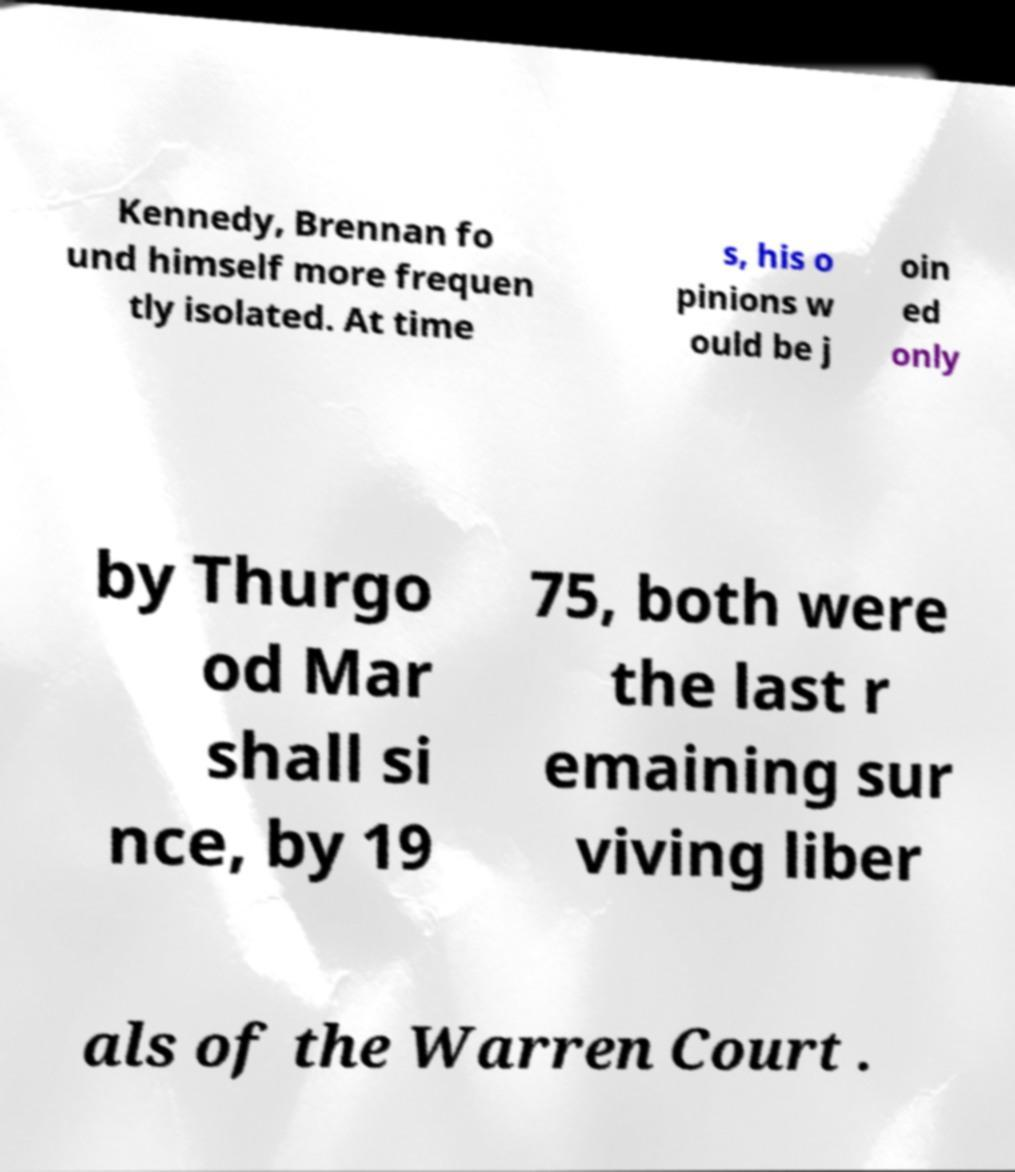Can you accurately transcribe the text from the provided image for me? Kennedy, Brennan fo und himself more frequen tly isolated. At time s, his o pinions w ould be j oin ed only by Thurgo od Mar shall si nce, by 19 75, both were the last r emaining sur viving liber als of the Warren Court . 